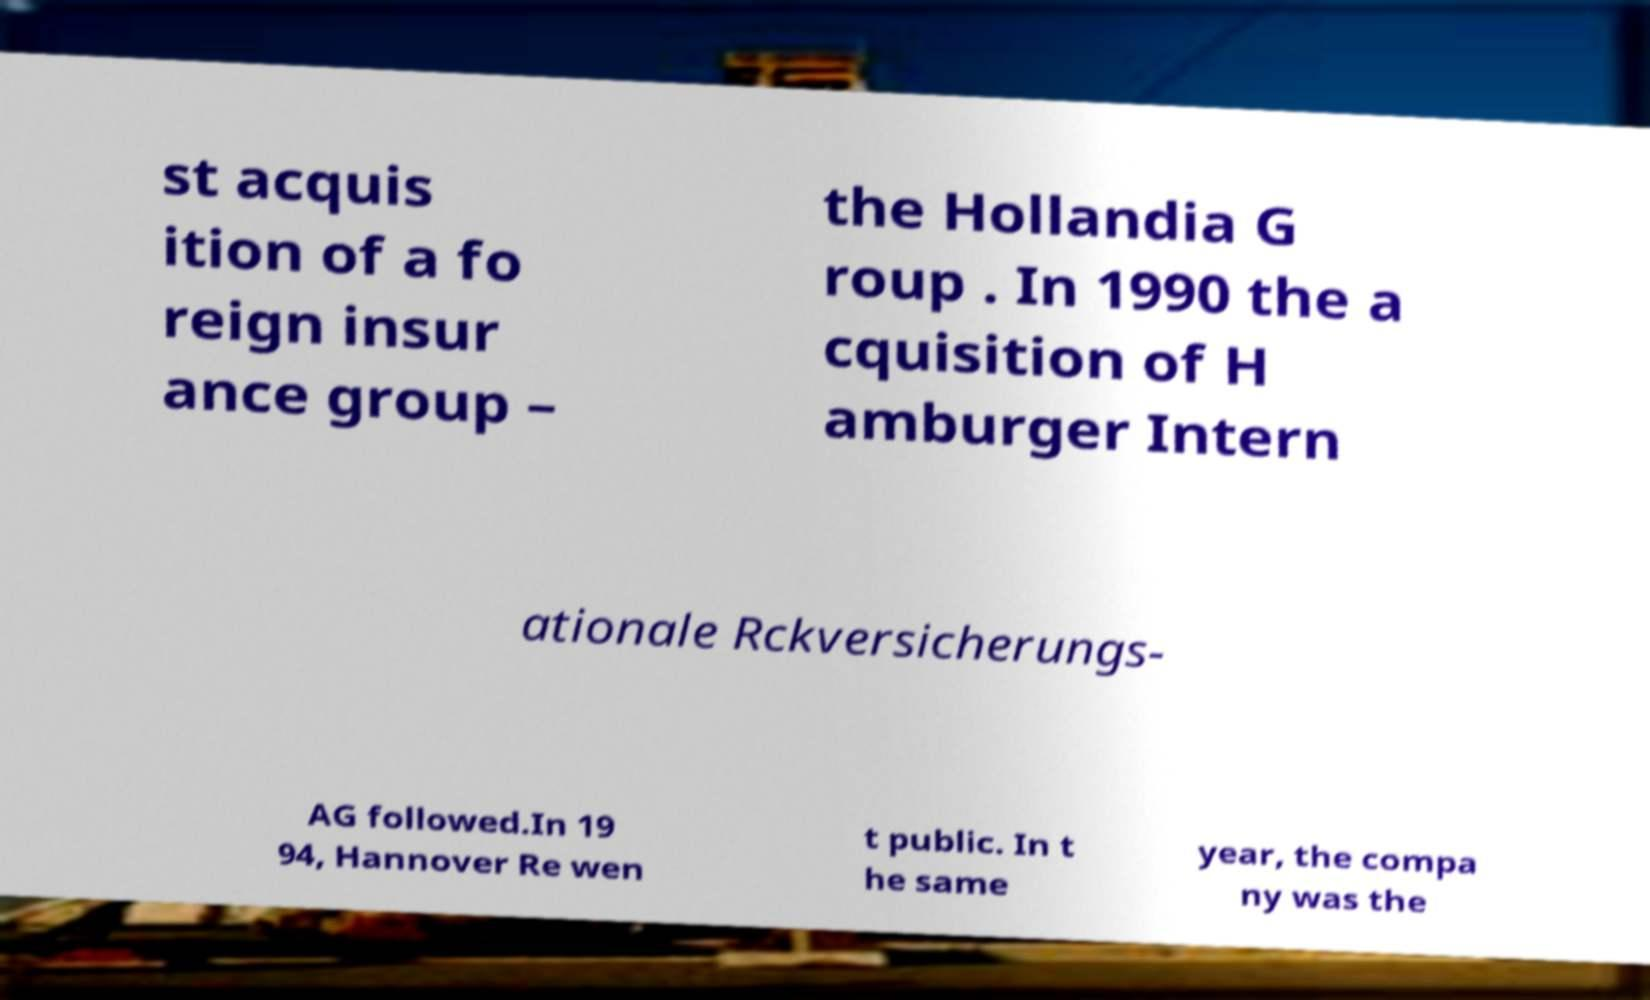Please read and relay the text visible in this image. What does it say? st acquis ition of a fo reign insur ance group – the Hollandia G roup . In 1990 the a cquisition of H amburger Intern ationale Rckversicherungs- AG followed.In 19 94, Hannover Re wen t public. In t he same year, the compa ny was the 